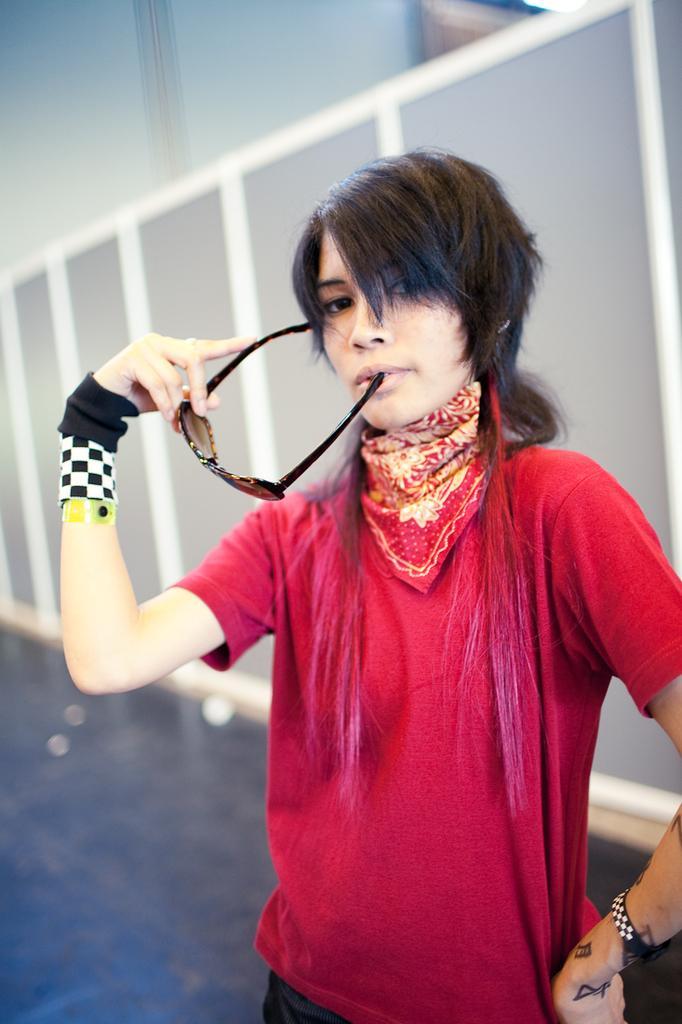Could you give a brief overview of what you see in this image? In this picture we can see a woman, she wore a red color T-shirt, and she is holding spectacles. 